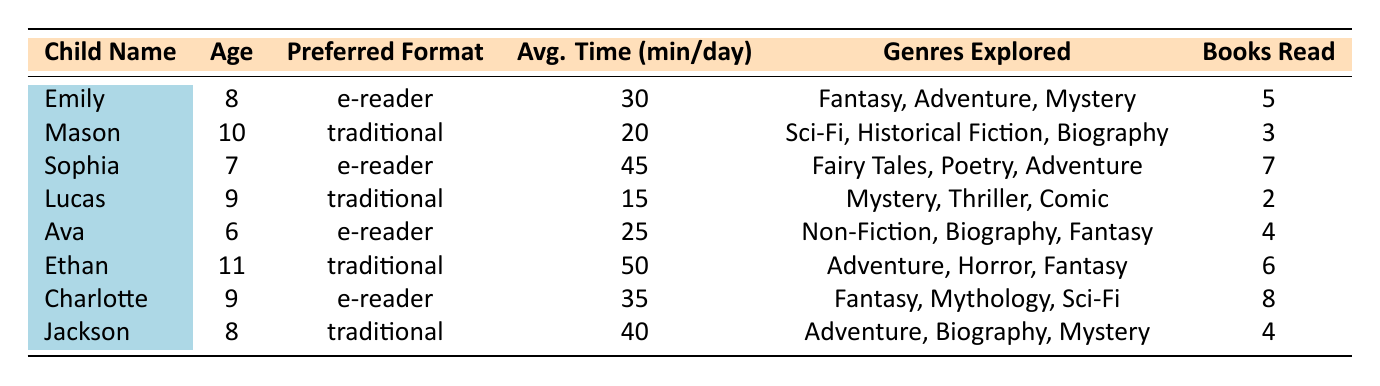What is the average time read per day for children using e-readers? To find the average time, we sum the average times of the children using e-readers: 30 + 45 + 25 + 35 = 135 minutes. There are 4 children using e-readers, so the average is 135/4 = 33.75 minutes.
Answer: 33.75 How many books did Sophia read last month? Sophia's data shows she read 7 books last month. This is a direct retrieval of a value from the table.
Answer: 7 Is Charlotte older than Ethan? Charlotte is 9 years old, while Ethan is 11 years old. Therefore, Charlotte is not older than Ethan. This requires a simple comparison of the ages from the table.
Answer: No Which child explored the most genres? Charlotte explored 3 genres (Fantasy, Mythology, Science Fiction), while no other child explored more than 3 genres. This is a direct comparison of the genres listed for each child.
Answer: Charlotte What is the total number of books read by children preferring traditional books? The total for traditional books is Mason's 3, Lucas's 2, Ethan's 6, and Jackson's 4, which adds up to 3 + 2 + 6 + 4 = 15. This requires summing the values of books read by each child in the traditional category.
Answer: 15 Which child has the highest average reading time? Ethan has the highest average reading time of 50 minutes per day. This requires comparing the average times listed for each child to identify the maximum value.
Answer: Ethan Does any child prefer e-readers and read more than 5 books last month? Sophia (7 books) and Charlotte (8 books) both prefer e-readers and read more than 5 books last month. This question requires checking preferences and their corresponding book counts for verification.
Answer: Yes What is the median age of the children who prefer traditional books? The ages of traditional book readers are 10 (Mason), 9 (Lucas), 11 (Ethan), and 8 (Jackson), which ordered are 8, 9, 10, 11. The median is the average of the two middle values: (9 + 10)/2 = 9.5. This requires finding and averaging the middle values in the sorted ages of those children.
Answer: 9.5 